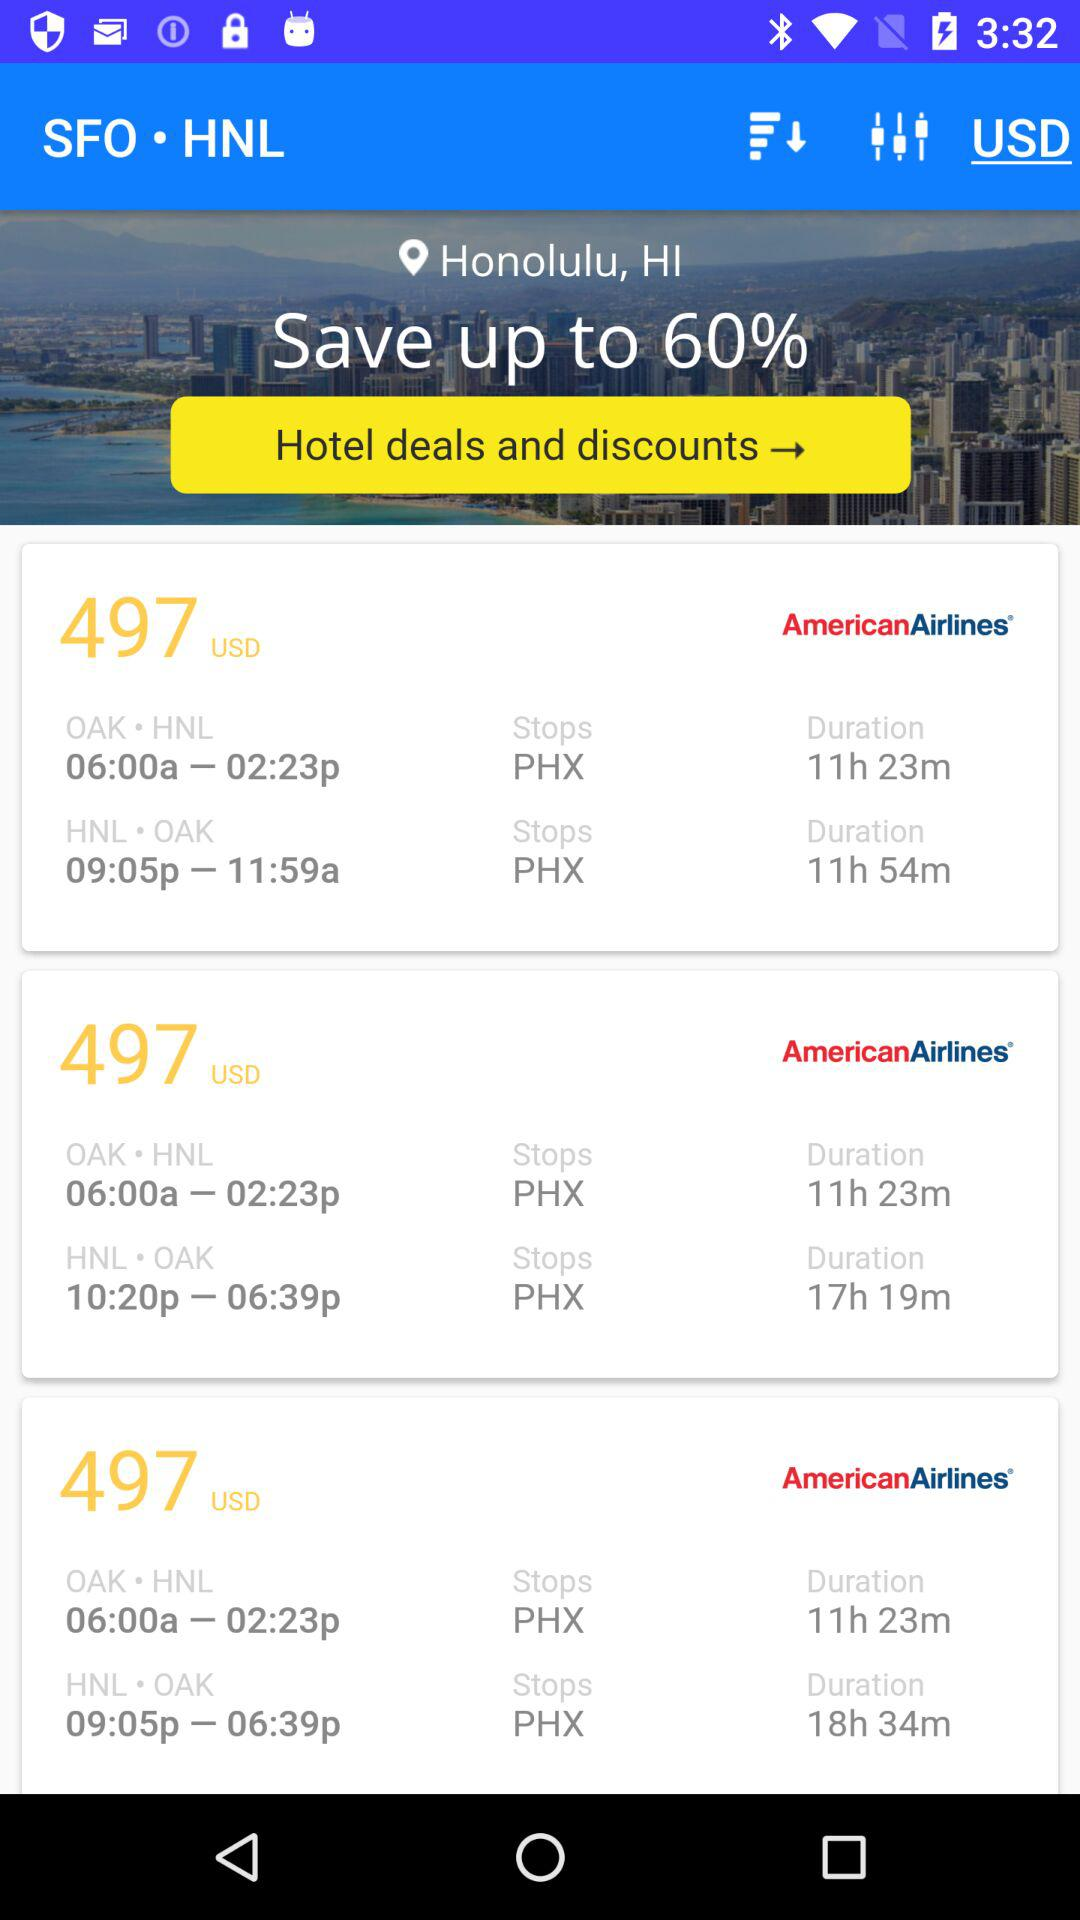How much of the percentage can be saved? The percentage that can be saved is up to 60. 